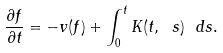<formula> <loc_0><loc_0><loc_500><loc_500>\frac { \partial f } { \partial t } = - v ( f ) + \int _ { 0 } ^ { t } K ( t , \ s ) \ d s .</formula> 